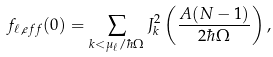Convert formula to latex. <formula><loc_0><loc_0><loc_500><loc_500>f _ { \ell , e f f } ( 0 ) = \sum _ { k < \mu _ { \ell } / \hbar { \Omega } } J _ { k } ^ { 2 } \left ( \frac { A ( N - 1 ) } { 2 \hbar { \Omega } } \right ) ,</formula> 